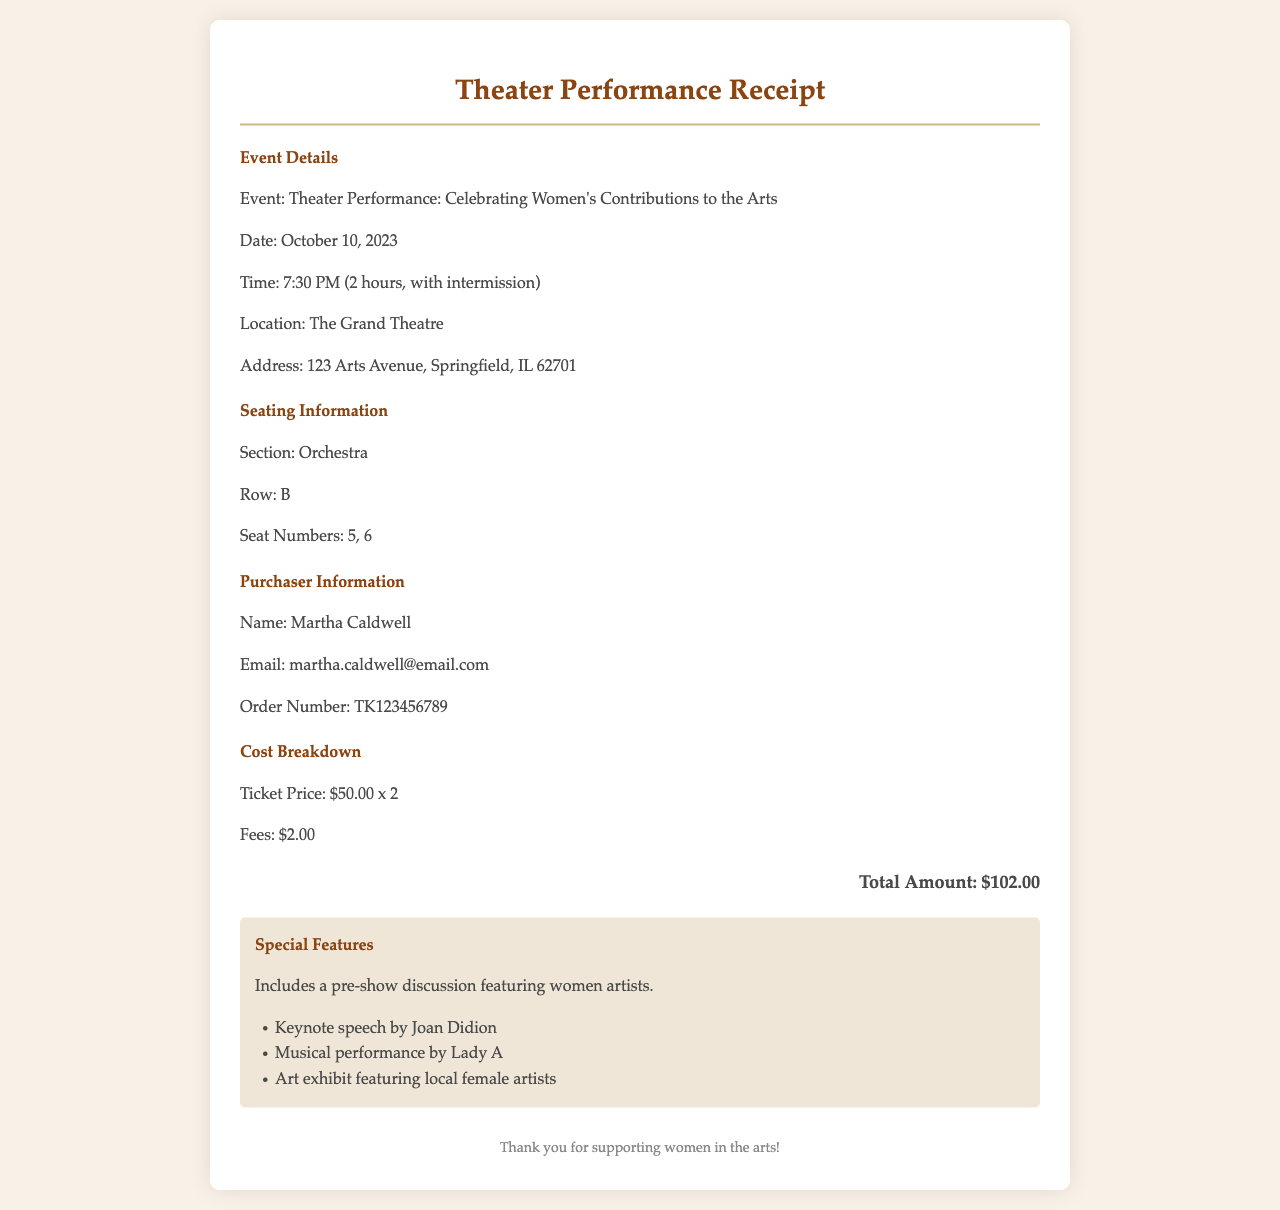What is the event title? The event title is stated in the document as "Theater Performance: Celebrating Women's Contributions to the Arts."
Answer: Celebrating Women's Contributions to the Arts When is the theater performance? The date of the theater performance is specified in the document.
Answer: October 10, 2023 What is the seating section for the purchased tickets? The seating section is mentioned in the seating information of the document.
Answer: Orchestra How many tickets were purchased? The number of tickets purchased can be found in the cost breakdown section of the document.
Answer: 2 What is the order number? The order number is listed under the purchaser information section of the document.
Answer: TK123456789 What is the total amount paid for the tickets? The total amount is explicitly mentioned in the cost breakdown section.
Answer: $102.00 Who is the purchaser of the tickets? The purchaser's name is provided in the document under the purchaser information section.
Answer: Martha Caldwell Which featured artist is mentioned for the pre-show discussion? The featured artist is indicated in the special features section of the document.
Answer: Joan Didion What time does the performance start? The start time is provided in the event details section of the document.
Answer: 7:30 PM 